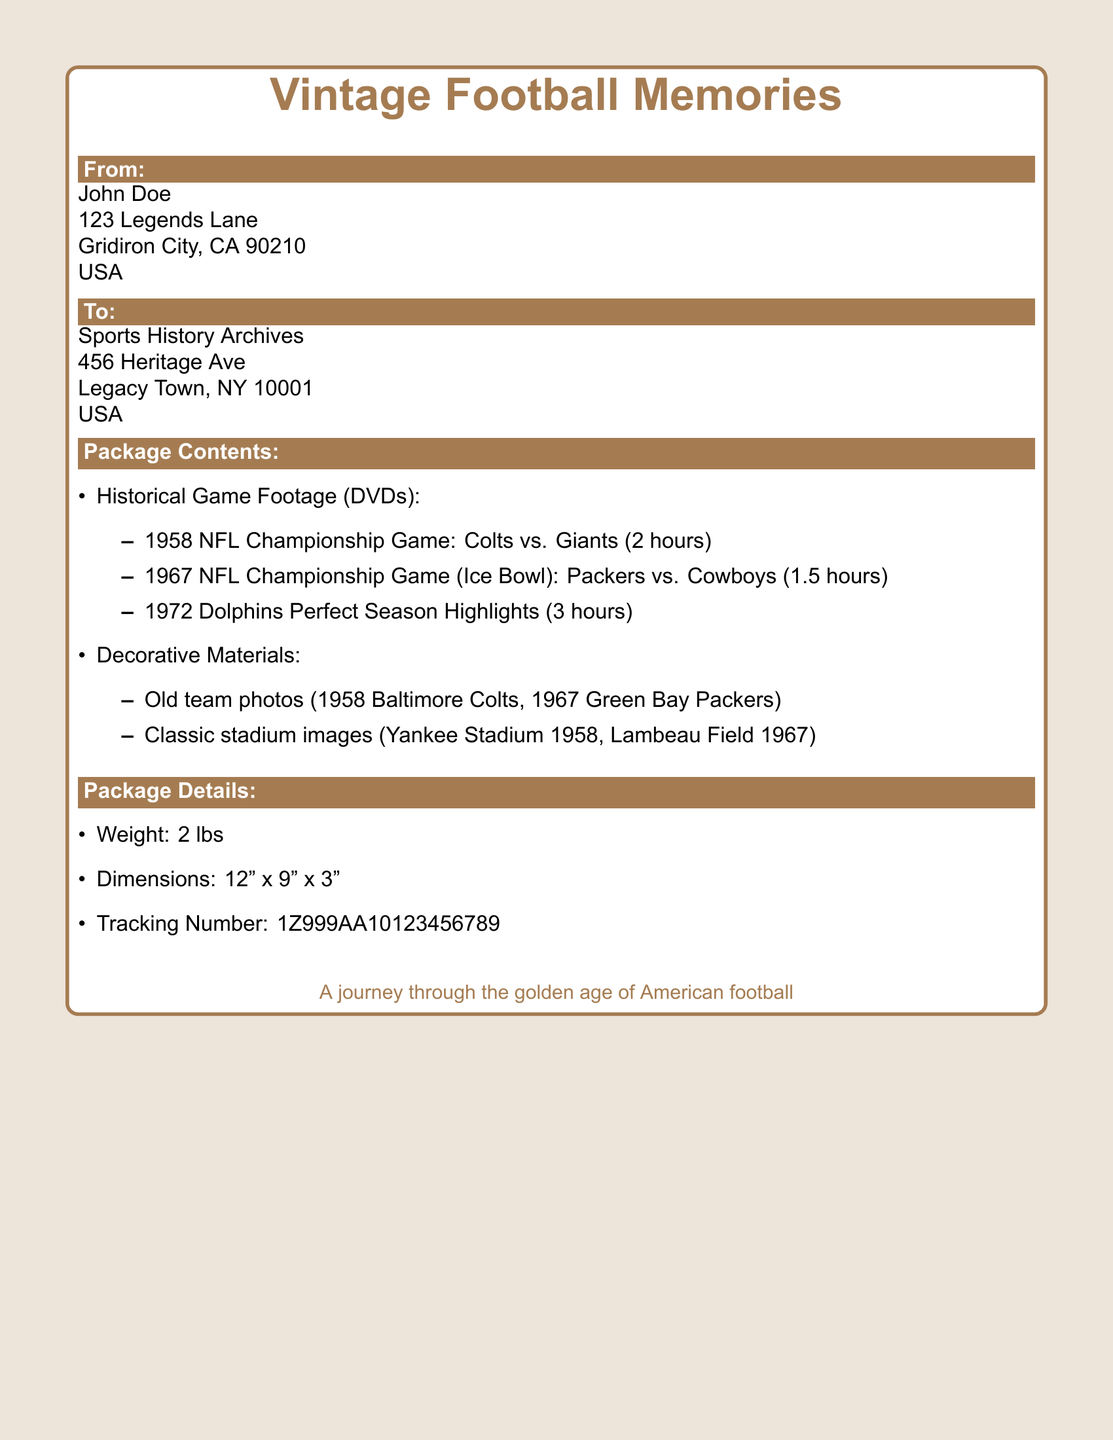What is the sender's name? The sender's name is mentioned in the "From" section of the document.
Answer: John Doe What is the weight of the package? The weight of the package is specified in the "Package Details" section.
Answer: 2 lbs What is the tracking number? The tracking number is listed in the "Package Details" section of the document.
Answer: 1Z999AA10123456789 Which two teams played in the 1958 NFL Championship Game? The game participants are listed in the "Package Contents" section under Historical Game Footage.
Answer: Colts vs. Giants What type of memories does the package contain? The title of the package at the top provides a summary of its content.
Answer: Vintage Football Memories What year is associated with the perfect season highlights? The year of the highlights is mentioned in the "Package Contents" section.
Answer: 1972 Which classic stadium image is included? The classic stadium images are mentioned in the "Package Contents" section.
Answer: Lambeau Field 1967 How many hours is the Ice Bowl footage? The duration of the Ice Bowl footage is listed in the "Package Contents" section.
Answer: 1.5 hours 